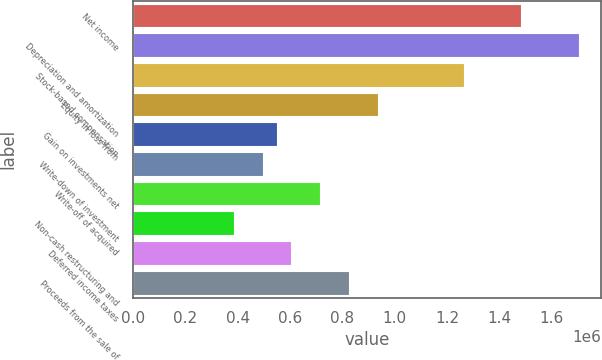Convert chart to OTSL. <chart><loc_0><loc_0><loc_500><loc_500><bar_chart><fcel>Net income<fcel>Depreciation and amortization<fcel>Stock-based compensation<fcel>Equity in loss from<fcel>Gain on investments net<fcel>Write-down of investment<fcel>Write-off of acquired<fcel>Non-cash restructuring and<fcel>Deferred income taxes<fcel>Proceeds from the sale of<nl><fcel>1.48393e+06<fcel>1.70371e+06<fcel>1.26414e+06<fcel>934460<fcel>549835<fcel>494888<fcel>714674<fcel>384996<fcel>604782<fcel>824568<nl></chart> 